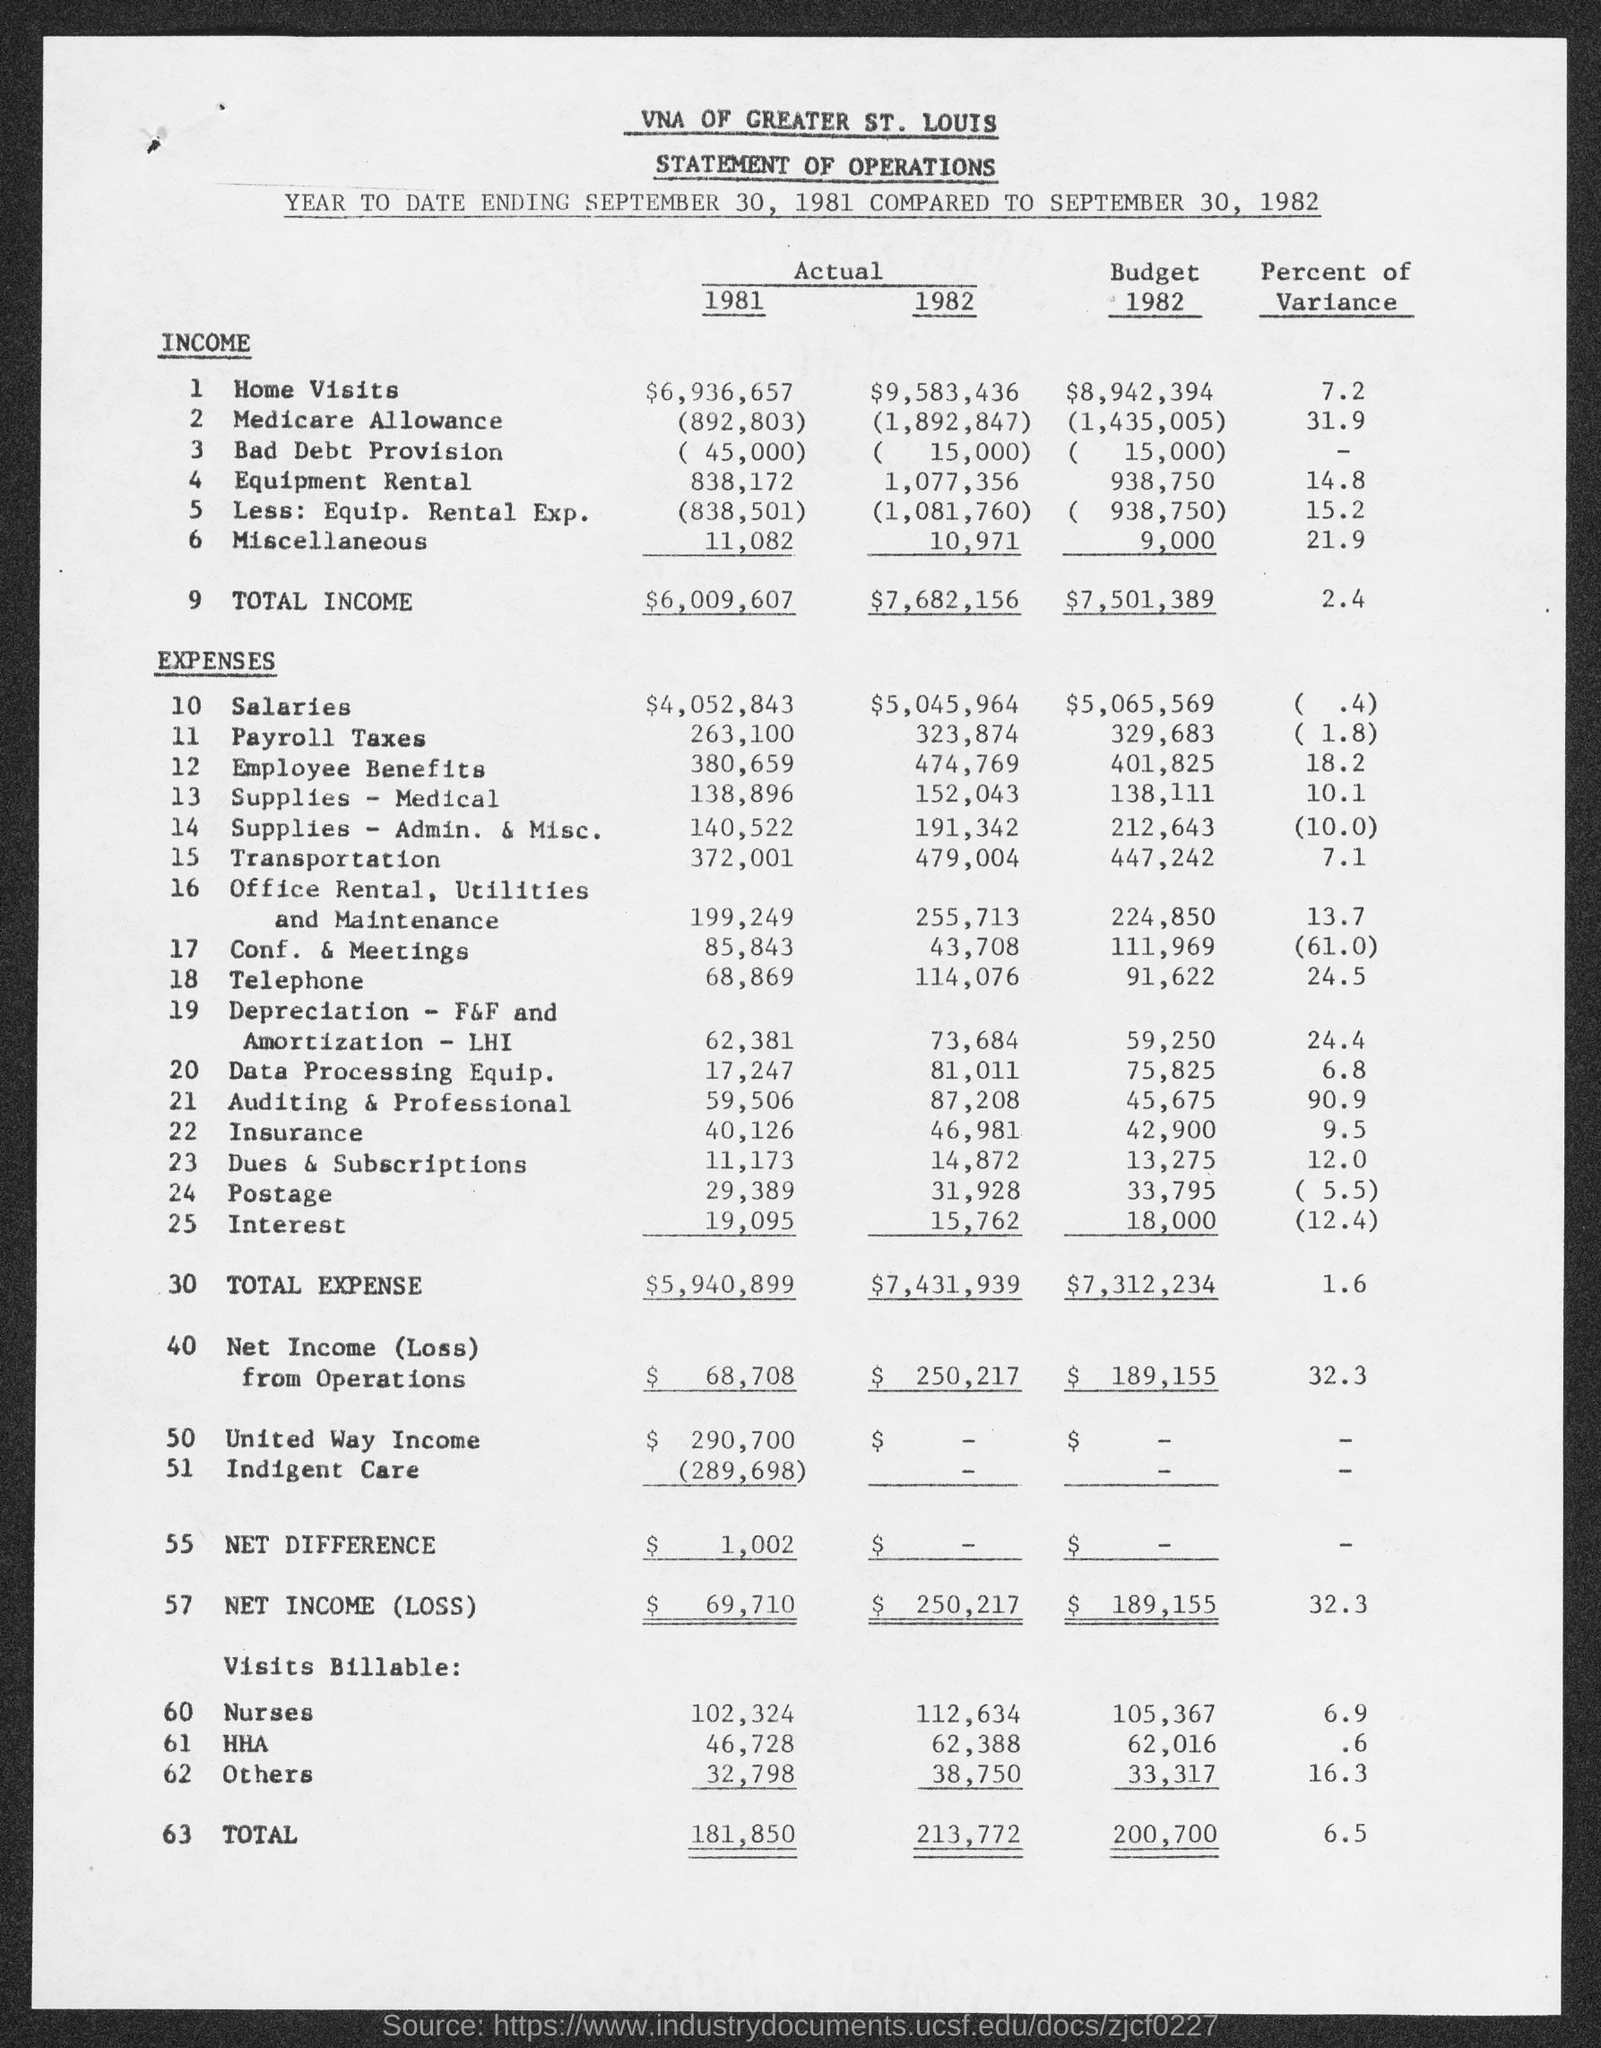What is mentioned in the second line of the title?
Your answer should be very brief. STATEMENT OF OPERATIONS. What is the Total Income corresponding to the year 1981 under the title "Actual"?
Make the answer very short. $6,009,607. Give the Percent of Variance for Others?
Provide a succinct answer. 16.3. 